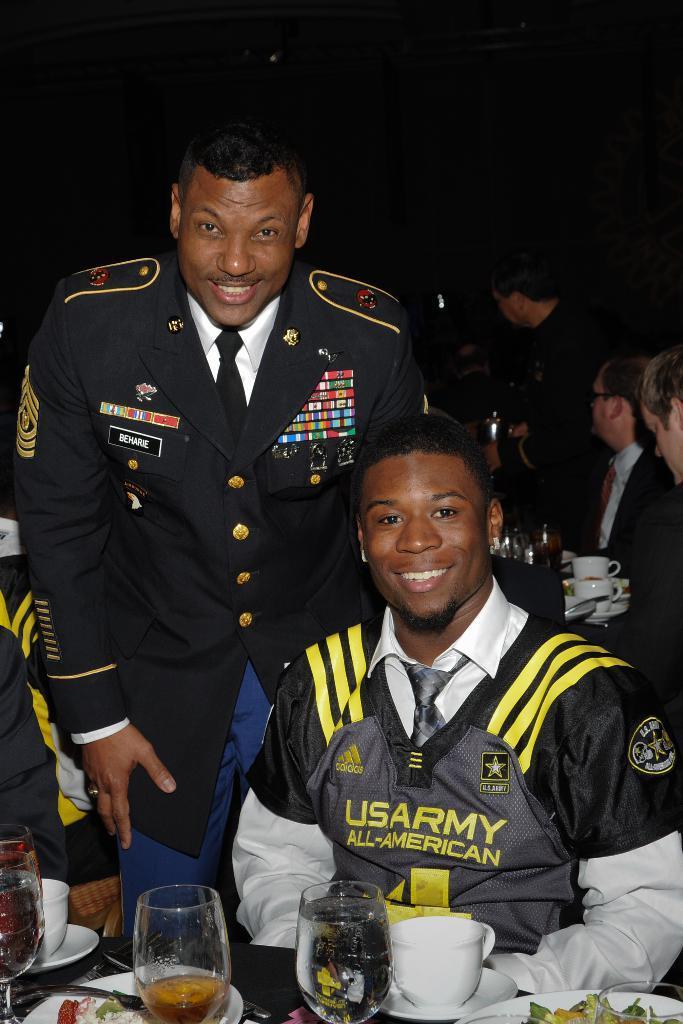Can you describe this image briefly? In this image I can see two persons, the person in front sitting and wearing white and gray color dress, and the person at back wearing black blazer, white shirt and black tie, in front I can see few glasses, plates. Background I can see few other persons. 